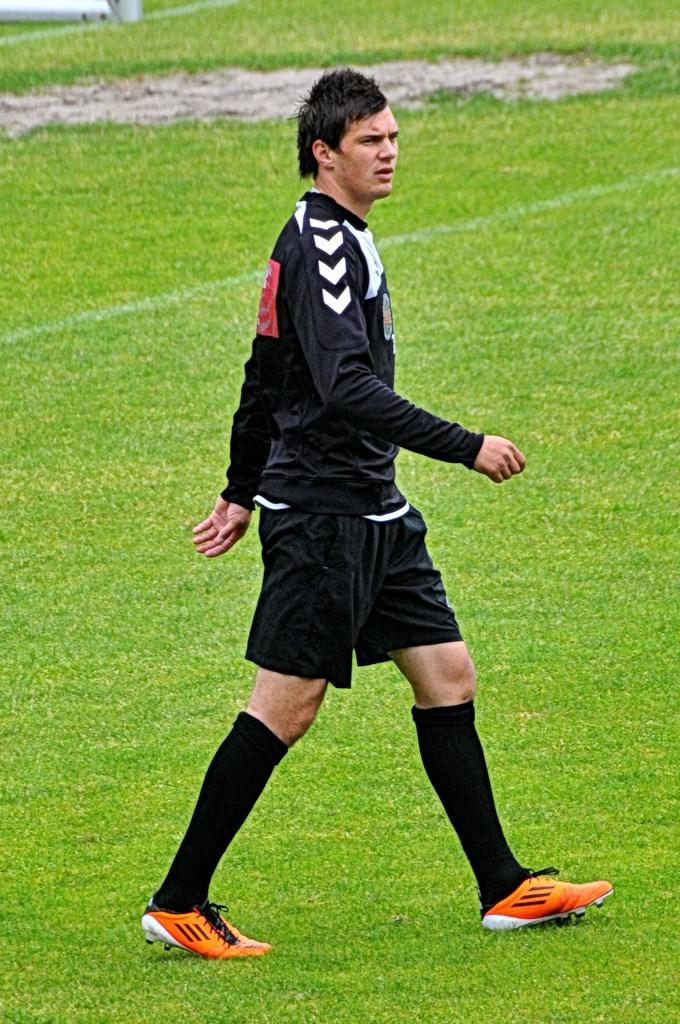What is the main subject of the image? There is a person in the image. What is the person doing in the image? The person is walking. Where is the person located in the image? The person is on the ground. What is the person wearing in the image? The person is wearing a black dress. What type of surface is the person walking on? There is grass on the ground. What type of furniture can be seen in the image? There is no furniture present in the image; it features a person walking on grass. What type of cloud is visible in the image? There is no cloud visible in the image; it is focused on a person walking on grass. 